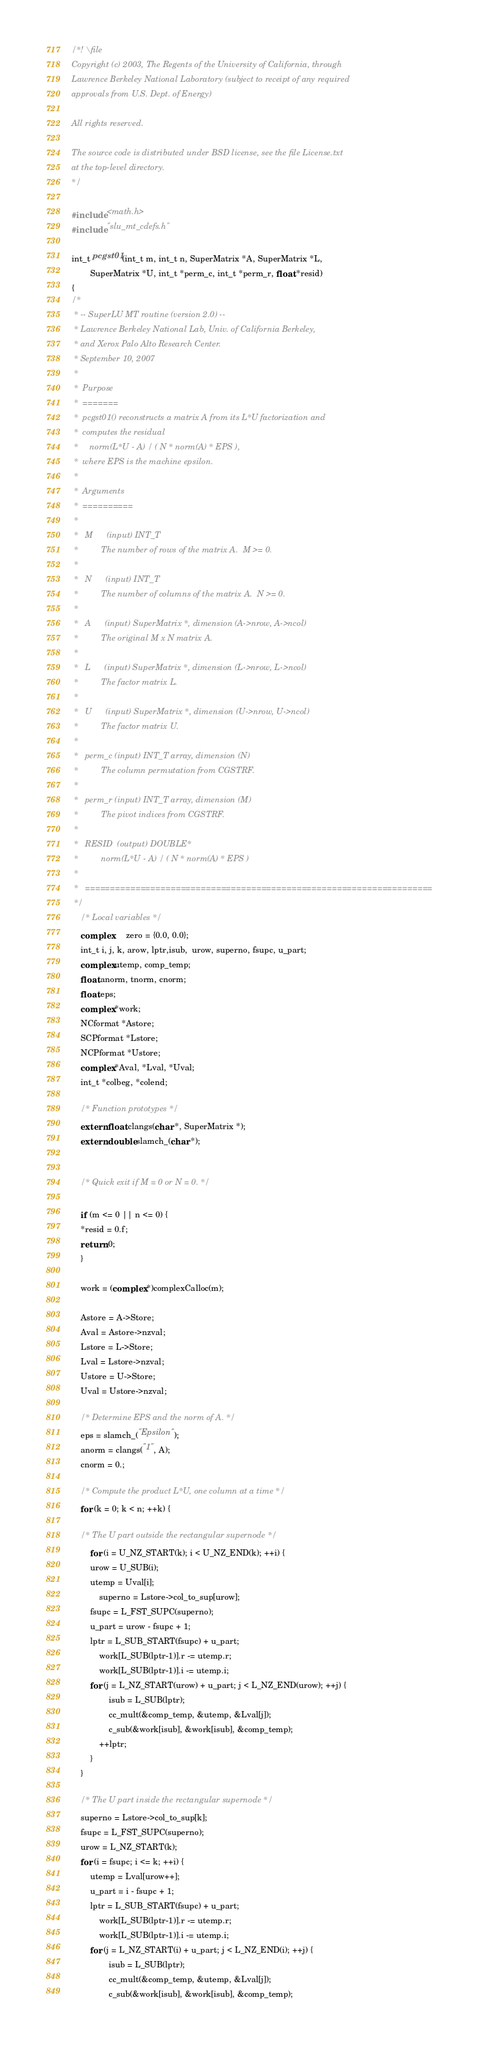<code> <loc_0><loc_0><loc_500><loc_500><_C_>/*! \file
Copyright (c) 2003, The Regents of the University of California, through
Lawrence Berkeley National Laboratory (subject to receipt of any required 
approvals from U.S. Dept. of Energy) 

All rights reserved. 

The source code is distributed under BSD license, see the file License.txt
at the top-level directory.
*/

#include <math.h>
#include "slu_mt_cdefs.h"

int_t pcgst01(int_t m, int_t n, SuperMatrix *A, SuperMatrix *L, 
	    SuperMatrix *U, int_t *perm_c, int_t *perm_r, float *resid)
{
/*
 * -- SuperLU MT routine (version 2.0) --
 * Lawrence Berkeley National Lab, Univ. of California Berkeley,
 * and Xerox Palo Alto Research Center.
 * September 10, 2007
 *
 *  Purpose   
 *  =======   
 *  pcgst01() reconstructs a matrix A from its L*U factorization and   
 *  computes the residual   
 *     norm(L*U - A) / ( N * norm(A) * EPS ),   
 *  where EPS is the machine epsilon.   
 *
 *  Arguments   
 *  ==========   
 *
 *   M      (input) INT_T   
 *          The number of rows of the matrix A.  M >= 0.  
 *
 *   N      (input) INT_T   
 *          The number of columns of the matrix A.  N >= 0.   
 *
 *   A      (input) SuperMatrix *, dimension (A->nrow, A->ncol)
 *          The original M x N matrix A.   
 *
 *   L      (input) SuperMatrix *, dimension (L->nrow, L->ncol)
 *          The factor matrix L.
 *
 *   U      (input) SuperMatrix *, dimension (U->nrow, U->ncol)
 *          The factor matrix U.
 *
 *   perm_c (input) INT_T array, dimension (N)
 *          The column permutation from CGSTRF.   
 *
 *   perm_r (input) INT_T array, dimension (M)
 *          The pivot indices from CGSTRF.
 *
 *   RESID  (output) DOUBLE*
 *          norm(L*U - A) / ( N * norm(A) * EPS )   
 *
 *   ===================================================================== 
 */
    /* Local variables */
    complex      zero = {0.0, 0.0};
    int_t i, j, k, arow, lptr,isub,  urow, superno, fsupc, u_part;
    complex utemp, comp_temp;
    float anorm, tnorm, cnorm;
    float eps;
    complex *work;
    NCformat *Astore;
    SCPformat *Lstore;
    NCPformat *Ustore;
    complex *Aval, *Lval, *Uval;
    int_t *colbeg, *colend;

    /* Function prototypes */
    extern float clangs(char *, SuperMatrix *);
    extern double slamch_(char *);


    /* Quick exit if M = 0 or N = 0. */

    if (m <= 0 || n <= 0) {
	*resid = 0.f;
	return 0;
    }

    work = (complex *)complexCalloc(m);

    Astore = A->Store;
    Aval = Astore->nzval;
    Lstore = L->Store;
    Lval = Lstore->nzval;
    Ustore = U->Store;
    Uval = Ustore->nzval;

    /* Determine EPS and the norm of A. */
    eps = slamch_("Epsilon");
    anorm = clangs("1", A);
    cnorm = 0.;

    /* Compute the product L*U, one column at a time */
    for (k = 0; k < n; ++k) {

	/* The U part outside the rectangular supernode */
        for (i = U_NZ_START(k); i < U_NZ_END(k); ++i) {
	    urow = U_SUB(i);
	    utemp = Uval[i];
            superno = Lstore->col_to_sup[urow];
	    fsupc = L_FST_SUPC(superno);
	    u_part = urow - fsupc + 1;
	    lptr = L_SUB_START(fsupc) + u_part;
            work[L_SUB(lptr-1)].r -= utemp.r;
            work[L_SUB(lptr-1)].i -= utemp.i;
	    for (j = L_NZ_START(urow) + u_part; j < L_NZ_END(urow); ++j) {
                isub = L_SUB(lptr);
                cc_mult(&comp_temp, &utemp, &Lval[j]);
                c_sub(&work[isub], &work[isub], &comp_temp);
	        ++lptr;
	    }
	}

	/* The U part inside the rectangular supernode */
	superno = Lstore->col_to_sup[k];
	fsupc = L_FST_SUPC(superno);
	urow = L_NZ_START(k);
	for (i = fsupc; i <= k; ++i) {
	    utemp = Lval[urow++];
	    u_part = i - fsupc + 1;
	    lptr = L_SUB_START(fsupc) + u_part;
            work[L_SUB(lptr-1)].r -= utemp.r;
            work[L_SUB(lptr-1)].i -= utemp.i;
	    for (j = L_NZ_START(i) + u_part; j < L_NZ_END(i); ++j) {
                isub = L_SUB(lptr);
                cc_mult(&comp_temp, &utemp, &Lval[j]);
                c_sub(&work[isub], &work[isub], &comp_temp);</code> 